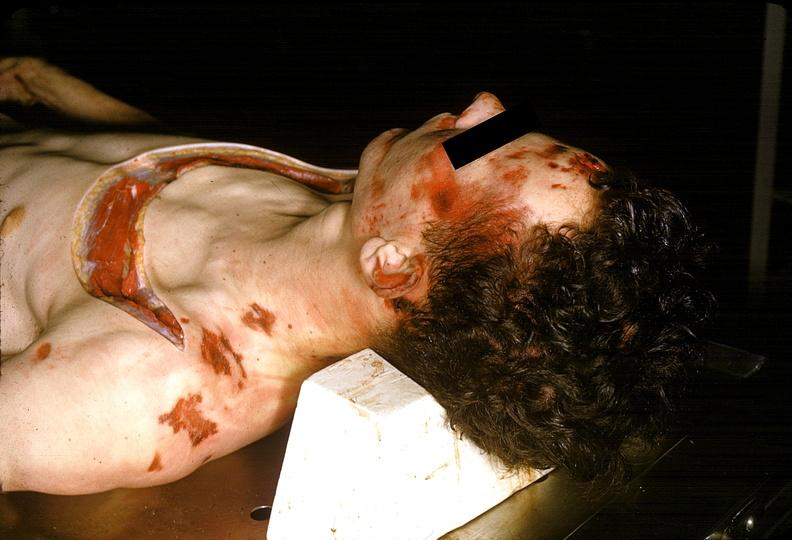does this image show severe trauma, contusion, lacerations, abrasions?
Answer the question using a single word or phrase. Yes 